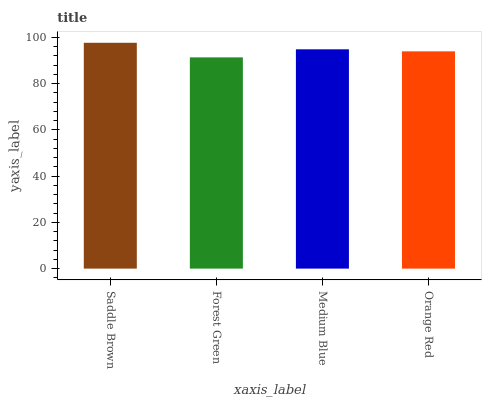Is Forest Green the minimum?
Answer yes or no. Yes. Is Saddle Brown the maximum?
Answer yes or no. Yes. Is Medium Blue the minimum?
Answer yes or no. No. Is Medium Blue the maximum?
Answer yes or no. No. Is Medium Blue greater than Forest Green?
Answer yes or no. Yes. Is Forest Green less than Medium Blue?
Answer yes or no. Yes. Is Forest Green greater than Medium Blue?
Answer yes or no. No. Is Medium Blue less than Forest Green?
Answer yes or no. No. Is Medium Blue the high median?
Answer yes or no. Yes. Is Orange Red the low median?
Answer yes or no. Yes. Is Saddle Brown the high median?
Answer yes or no. No. Is Saddle Brown the low median?
Answer yes or no. No. 